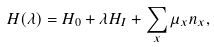<formula> <loc_0><loc_0><loc_500><loc_500>H ( \lambda ) = H _ { 0 } + \lambda H _ { I } + \sum _ { x } \mu _ { x } n _ { x } ,</formula> 